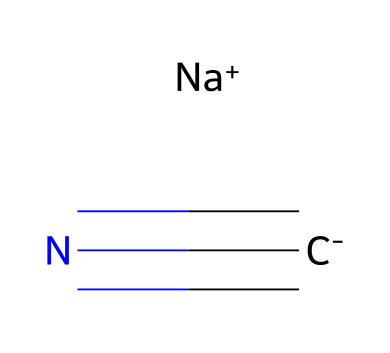What is the name of this compound? The SMILES representation of the compound indicates it is sodium cyanide, as it contains the sodium ion and the cyanide ion. Sodium cyanide is commonly known in the context of gold leaching operations.
Answer: sodium cyanide How many different elements are present in the structure? Analyzing the SMILES structure, we identify sodium (Na), carbon (C), and nitrogen (N) as the elements present. Therefore, there are three distinct elements in this compound.
Answer: three What type of bond is present between carbon and nitrogen? The bond between carbon and nitrogen in the cyanide ion is a triple bond, which can be inferred from the # symbol in the SMILES representation. This indicates that carbon is triple-bonded to nitrogen, a key feature of cyanide.
Answer: triple bond What is the charge of the sodium ion in the structure? The SMILES notation indicates that the sodium ion is annotated with "Na+", which explicitly shows its positive charge. Therefore, the sodium ion carries a +1 charge.
Answer: +1 What functional group is indicated by the structure of sodium cyanide? The presence of the cyanide ion, characterized by the -C≡N (triple bond between carbon and nitrogen), shows that the functional group is a nitrile. Nitriles are defined by the carbon-nitrogen triple bond.
Answer: nitrile Is this compound soluble in water? Sodium cyanide is known to be highly soluble in water, a property associated with many ionic compounds. This is consistent with the presence of the sodium ion, which facilitates its solubility.
Answer: yes 